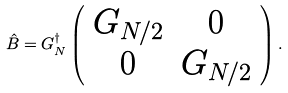Convert formula to latex. <formula><loc_0><loc_0><loc_500><loc_500>\hat { B } = G ^ { \dagger } _ { N } \left ( \begin{array} { c c } G _ { N / 2 } & 0 \\ 0 & G _ { N / 2 } \\ \end{array} \right ) .</formula> 